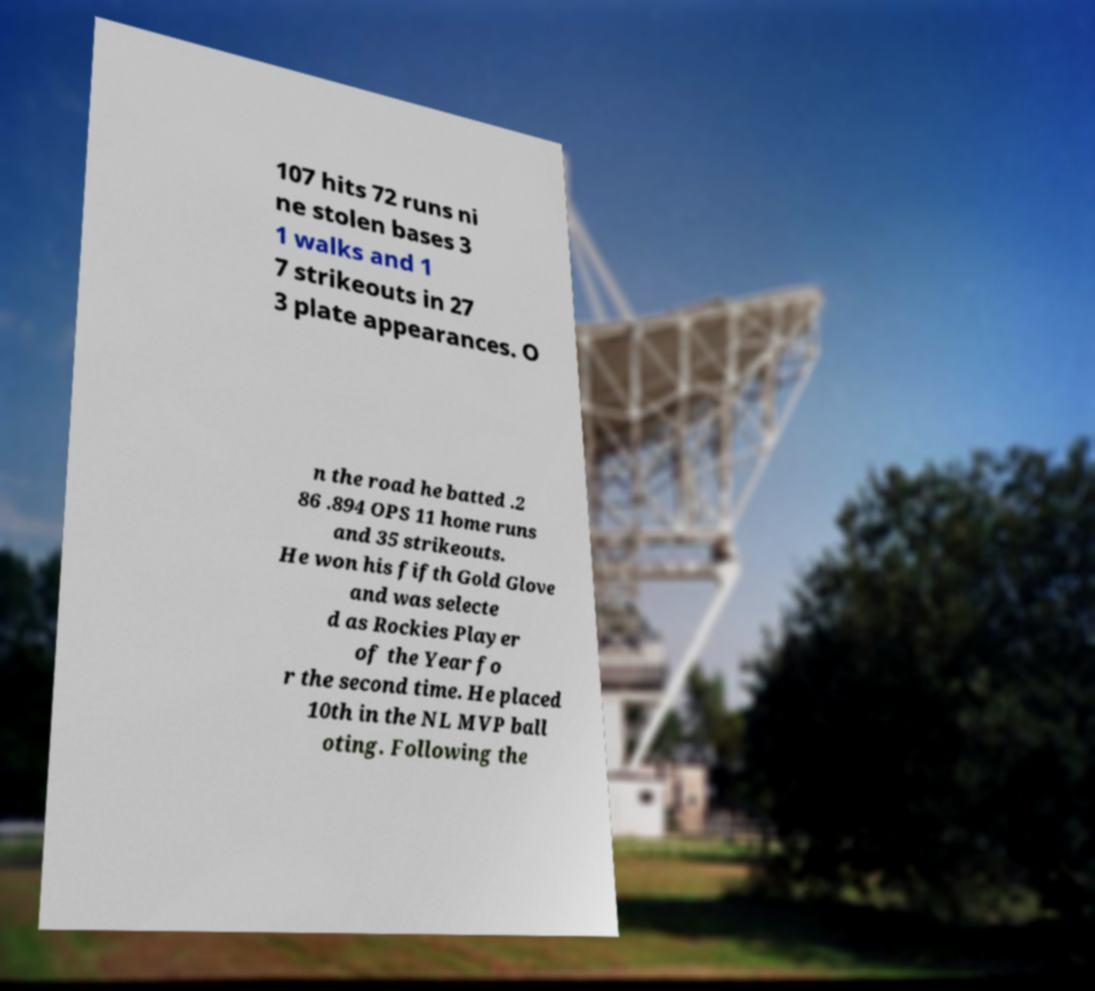What messages or text are displayed in this image? I need them in a readable, typed format. 107 hits 72 runs ni ne stolen bases 3 1 walks and 1 7 strikeouts in 27 3 plate appearances. O n the road he batted .2 86 .894 OPS 11 home runs and 35 strikeouts. He won his fifth Gold Glove and was selecte d as Rockies Player of the Year fo r the second time. He placed 10th in the NL MVP ball oting. Following the 